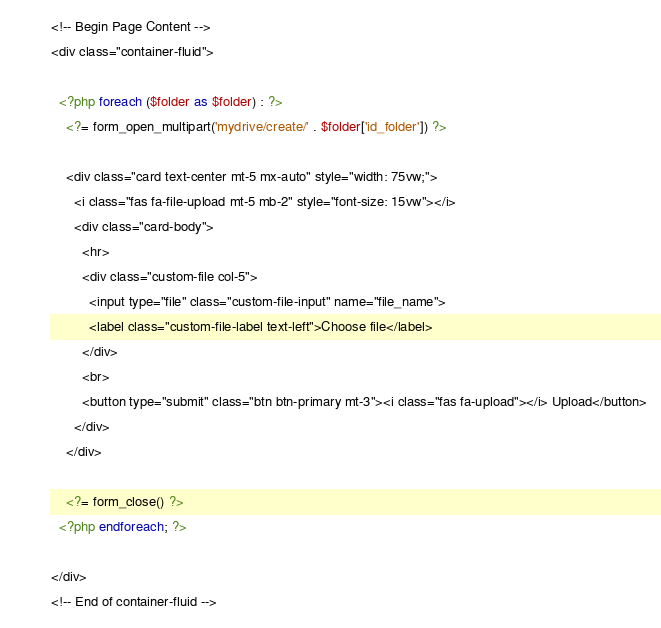Convert code to text. <code><loc_0><loc_0><loc_500><loc_500><_PHP_><!-- Begin Page Content -->
<div class="container-fluid">

  <?php foreach ($folder as $folder) : ?>
    <?= form_open_multipart('mydrive/create/' . $folder['id_folder']) ?>

    <div class="card text-center mt-5 mx-auto" style="width: 75vw;">
      <i class="fas fa-file-upload mt-5 mb-2" style="font-size: 15vw"></i>
      <div class="card-body">
        <hr>
        <div class="custom-file col-5">
          <input type="file" class="custom-file-input" name="file_name">
          <label class="custom-file-label text-left">Choose file</label>
        </div>
        <br>
        <button type="submit" class="btn btn-primary mt-3"><i class="fas fa-upload"></i> Upload</button>
      </div>
    </div>

    <?= form_close() ?>
  <?php endforeach; ?>

</div>
<!-- End of container-fluid --></code> 